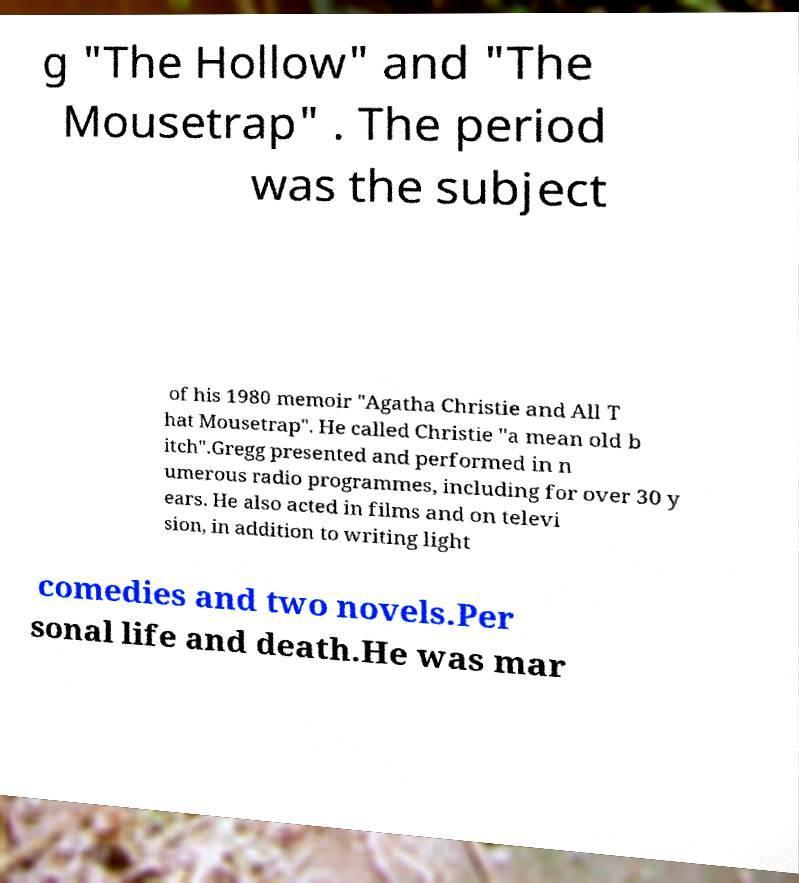For documentation purposes, I need the text within this image transcribed. Could you provide that? g "The Hollow" and "The Mousetrap" . The period was the subject of his 1980 memoir "Agatha Christie and All T hat Mousetrap". He called Christie "a mean old b itch".Gregg presented and performed in n umerous radio programmes, including for over 30 y ears. He also acted in films and on televi sion, in addition to writing light comedies and two novels.Per sonal life and death.He was mar 